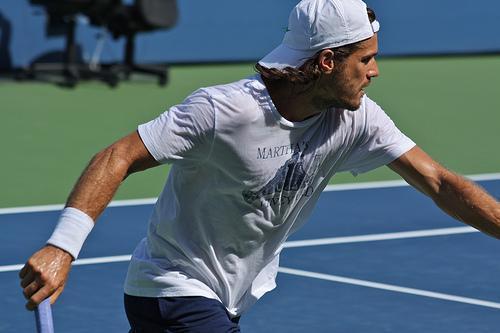How many people are in this photo?
Give a very brief answer. 1. How many people are playing football?
Give a very brief answer. 0. 